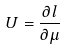Convert formula to latex. <formula><loc_0><loc_0><loc_500><loc_500>U = \frac { \partial l } { \partial \mu }</formula> 